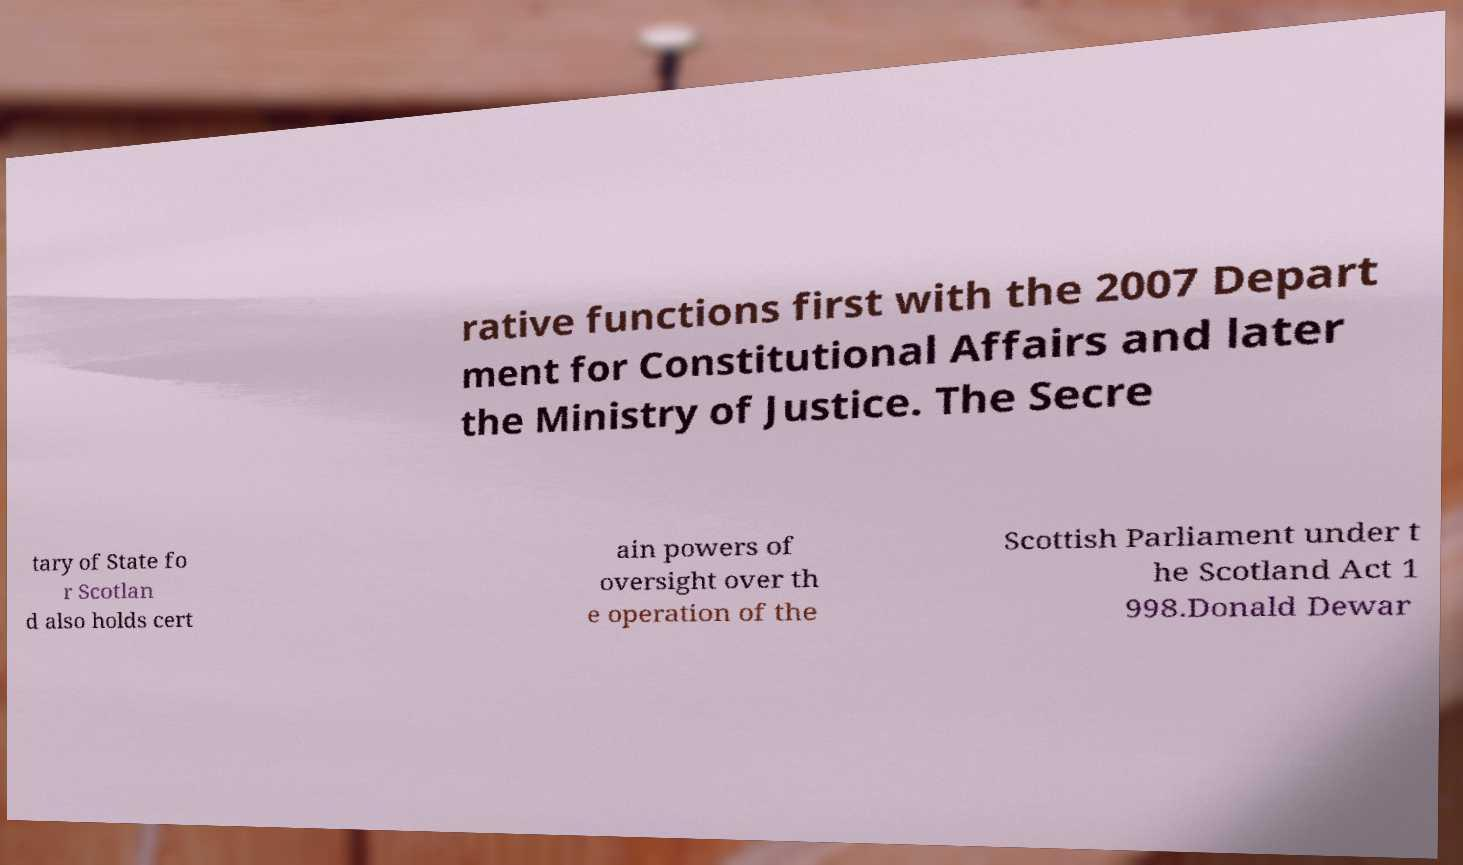Please identify and transcribe the text found in this image. rative functions first with the 2007 Depart ment for Constitutional Affairs and later the Ministry of Justice. The Secre tary of State fo r Scotlan d also holds cert ain powers of oversight over th e operation of the Scottish Parliament under t he Scotland Act 1 998.Donald Dewar 